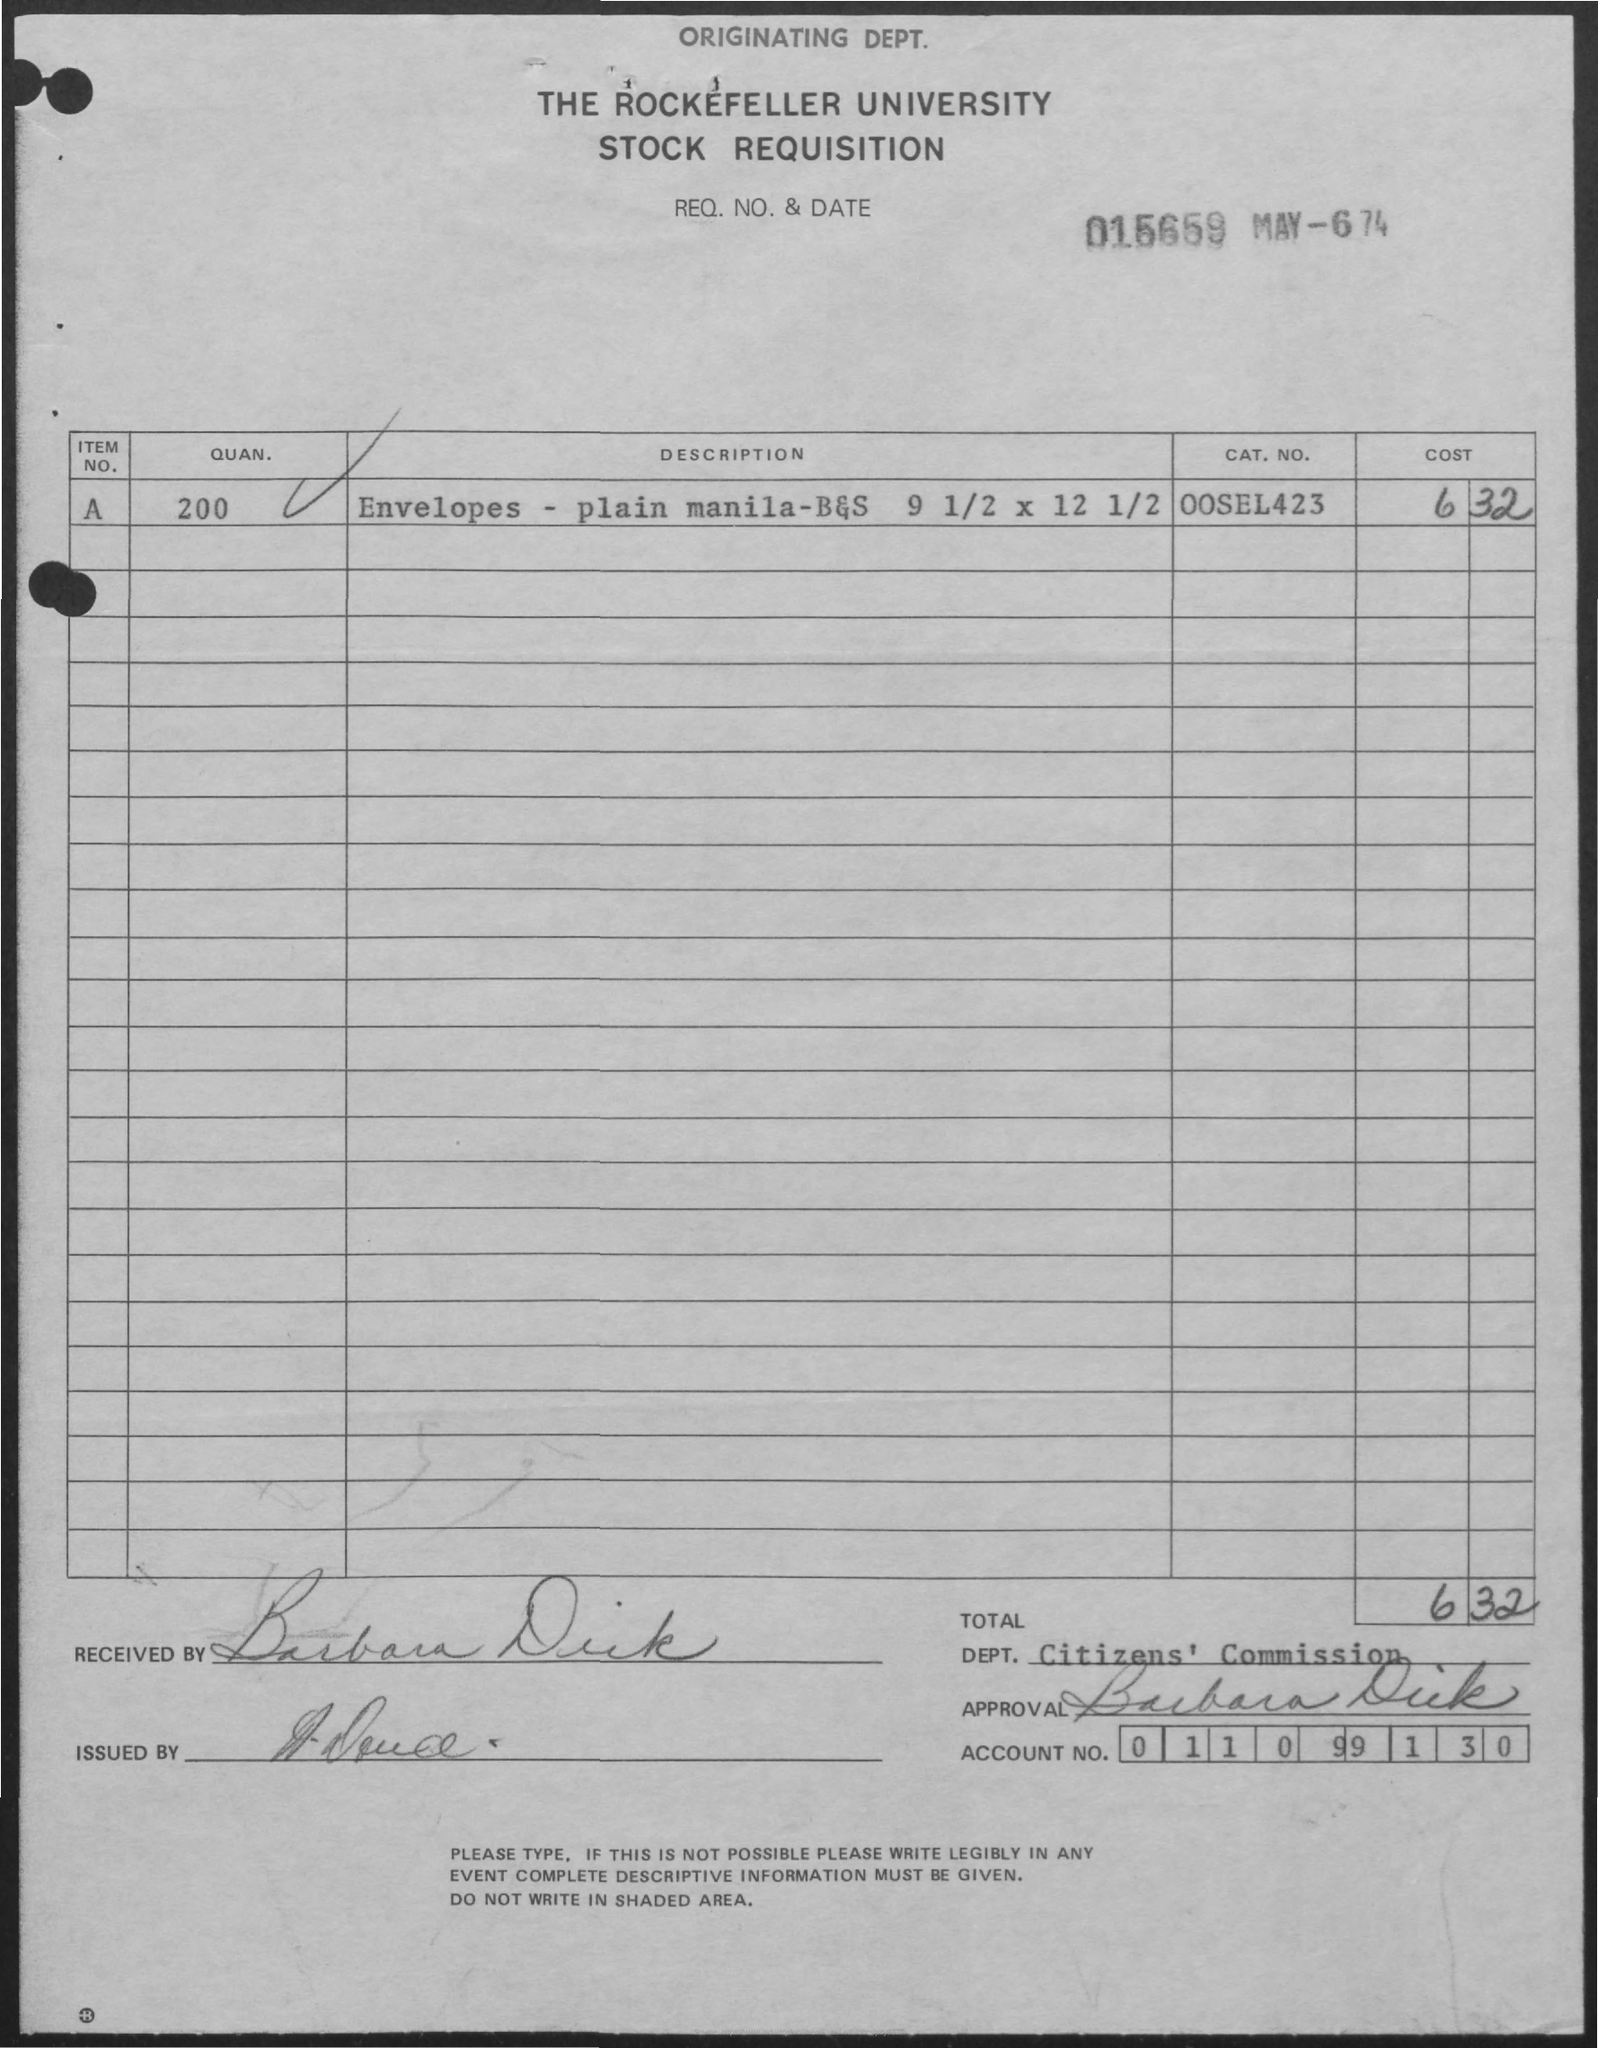Draw attention to some important aspects in this diagram. The total cost is 632. The quantity of item number A is 200. The account number is "011099130. The category number of item number A is unknown. The item number A is represented by the string "00sel423..". It is not clear what this item is, or what category it belongs to. The date is May 6, 1974. 